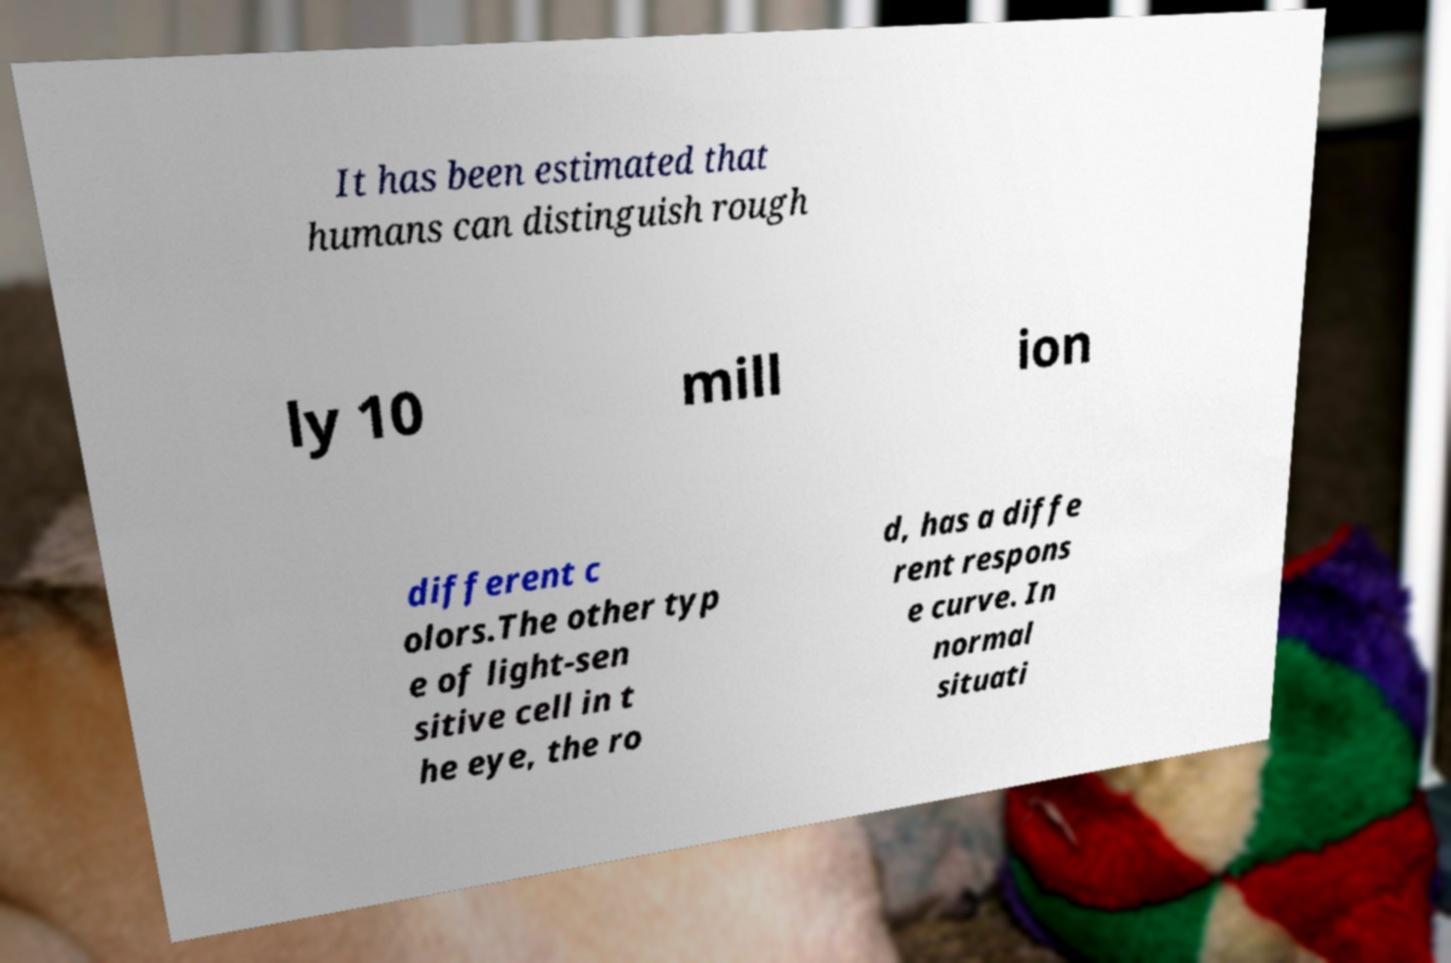There's text embedded in this image that I need extracted. Can you transcribe it verbatim? It has been estimated that humans can distinguish rough ly 10 mill ion different c olors.The other typ e of light-sen sitive cell in t he eye, the ro d, has a diffe rent respons e curve. In normal situati 